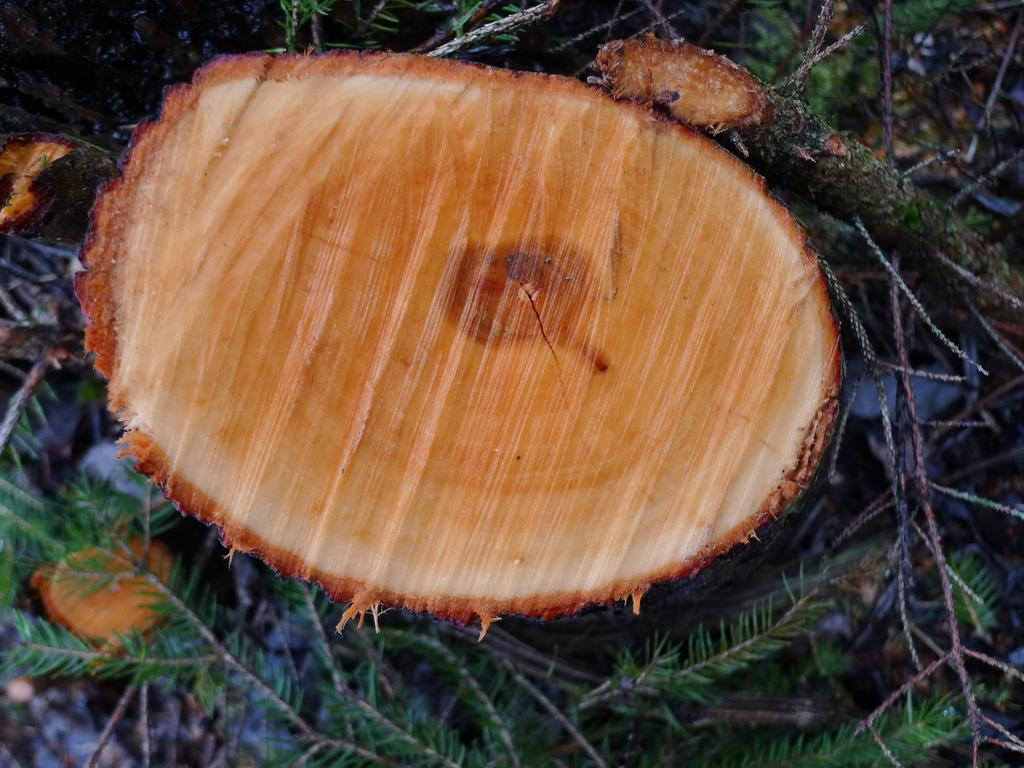What is the main object in the center of the image? There is a piece of wood in the center of the image. Where is the piece of wood located? The piece of wood is on the grass. What type of brick can be seen crushing the carriage in the image? There is no brick or carriage present in the image; it only features a piece of wood on the grass. 